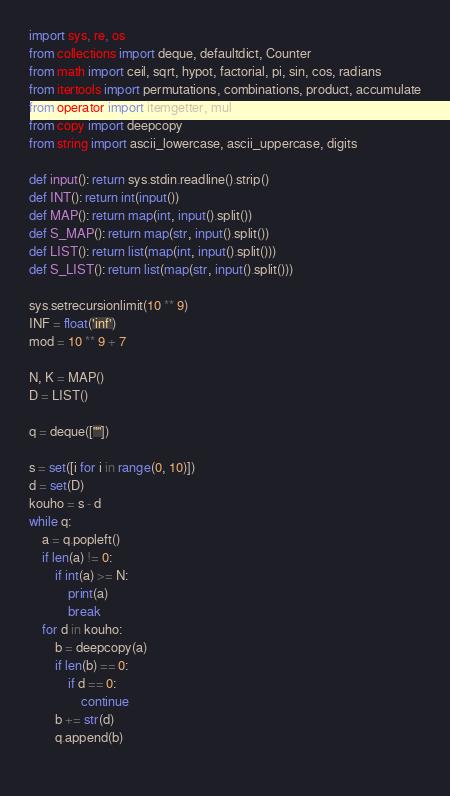<code> <loc_0><loc_0><loc_500><loc_500><_Python_>import sys, re, os
from collections import deque, defaultdict, Counter
from math import ceil, sqrt, hypot, factorial, pi, sin, cos, radians
from itertools import permutations, combinations, product, accumulate
from operator import itemgetter, mul
from copy import deepcopy
from string import ascii_lowercase, ascii_uppercase, digits

def input(): return sys.stdin.readline().strip()
def INT(): return int(input())
def MAP(): return map(int, input().split())
def S_MAP(): return map(str, input().split())
def LIST(): return list(map(int, input().split()))
def S_LIST(): return list(map(str, input().split()))
 
sys.setrecursionlimit(10 ** 9)
INF = float('inf')
mod = 10 ** 9 + 7

N, K = MAP()
D = LIST()

q = deque([""])

s = set([i for i in range(0, 10)]) 
d = set(D)
kouho = s - d
while q:
    a = q.popleft()
    if len(a) != 0:
        if int(a) >= N:
            print(a)
            break
    for d in kouho:
        b = deepcopy(a)
        if len(b) == 0:
            if d == 0:
                continue
        b += str(d)
        q.append(b)
    


</code> 